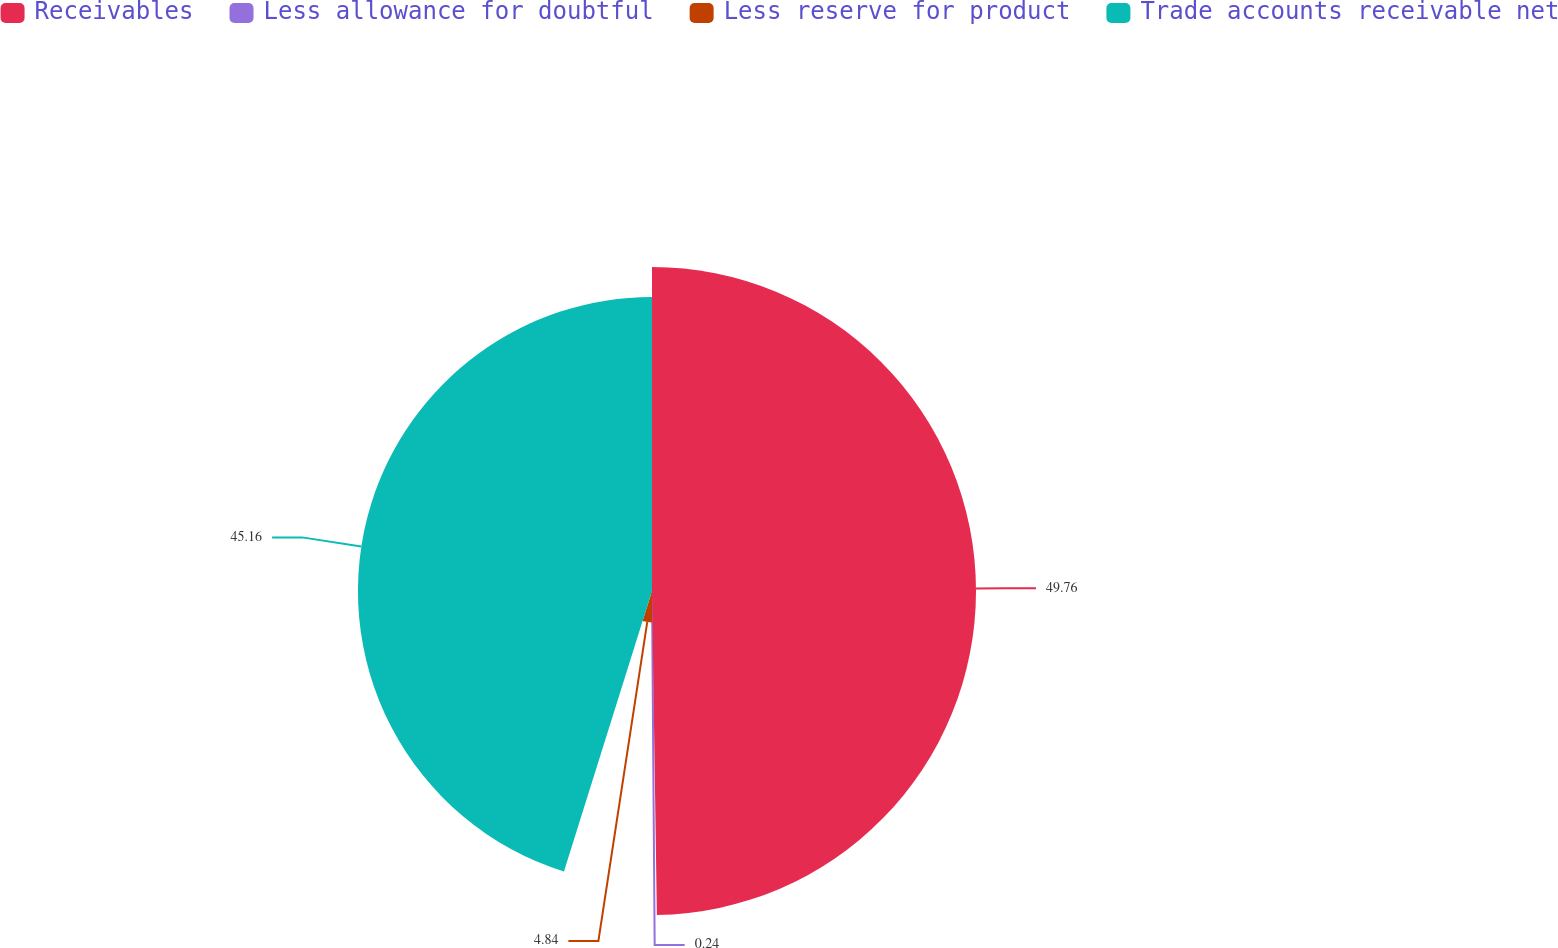<chart> <loc_0><loc_0><loc_500><loc_500><pie_chart><fcel>Receivables<fcel>Less allowance for doubtful<fcel>Less reserve for product<fcel>Trade accounts receivable net<nl><fcel>49.76%<fcel>0.24%<fcel>4.84%<fcel>45.16%<nl></chart> 